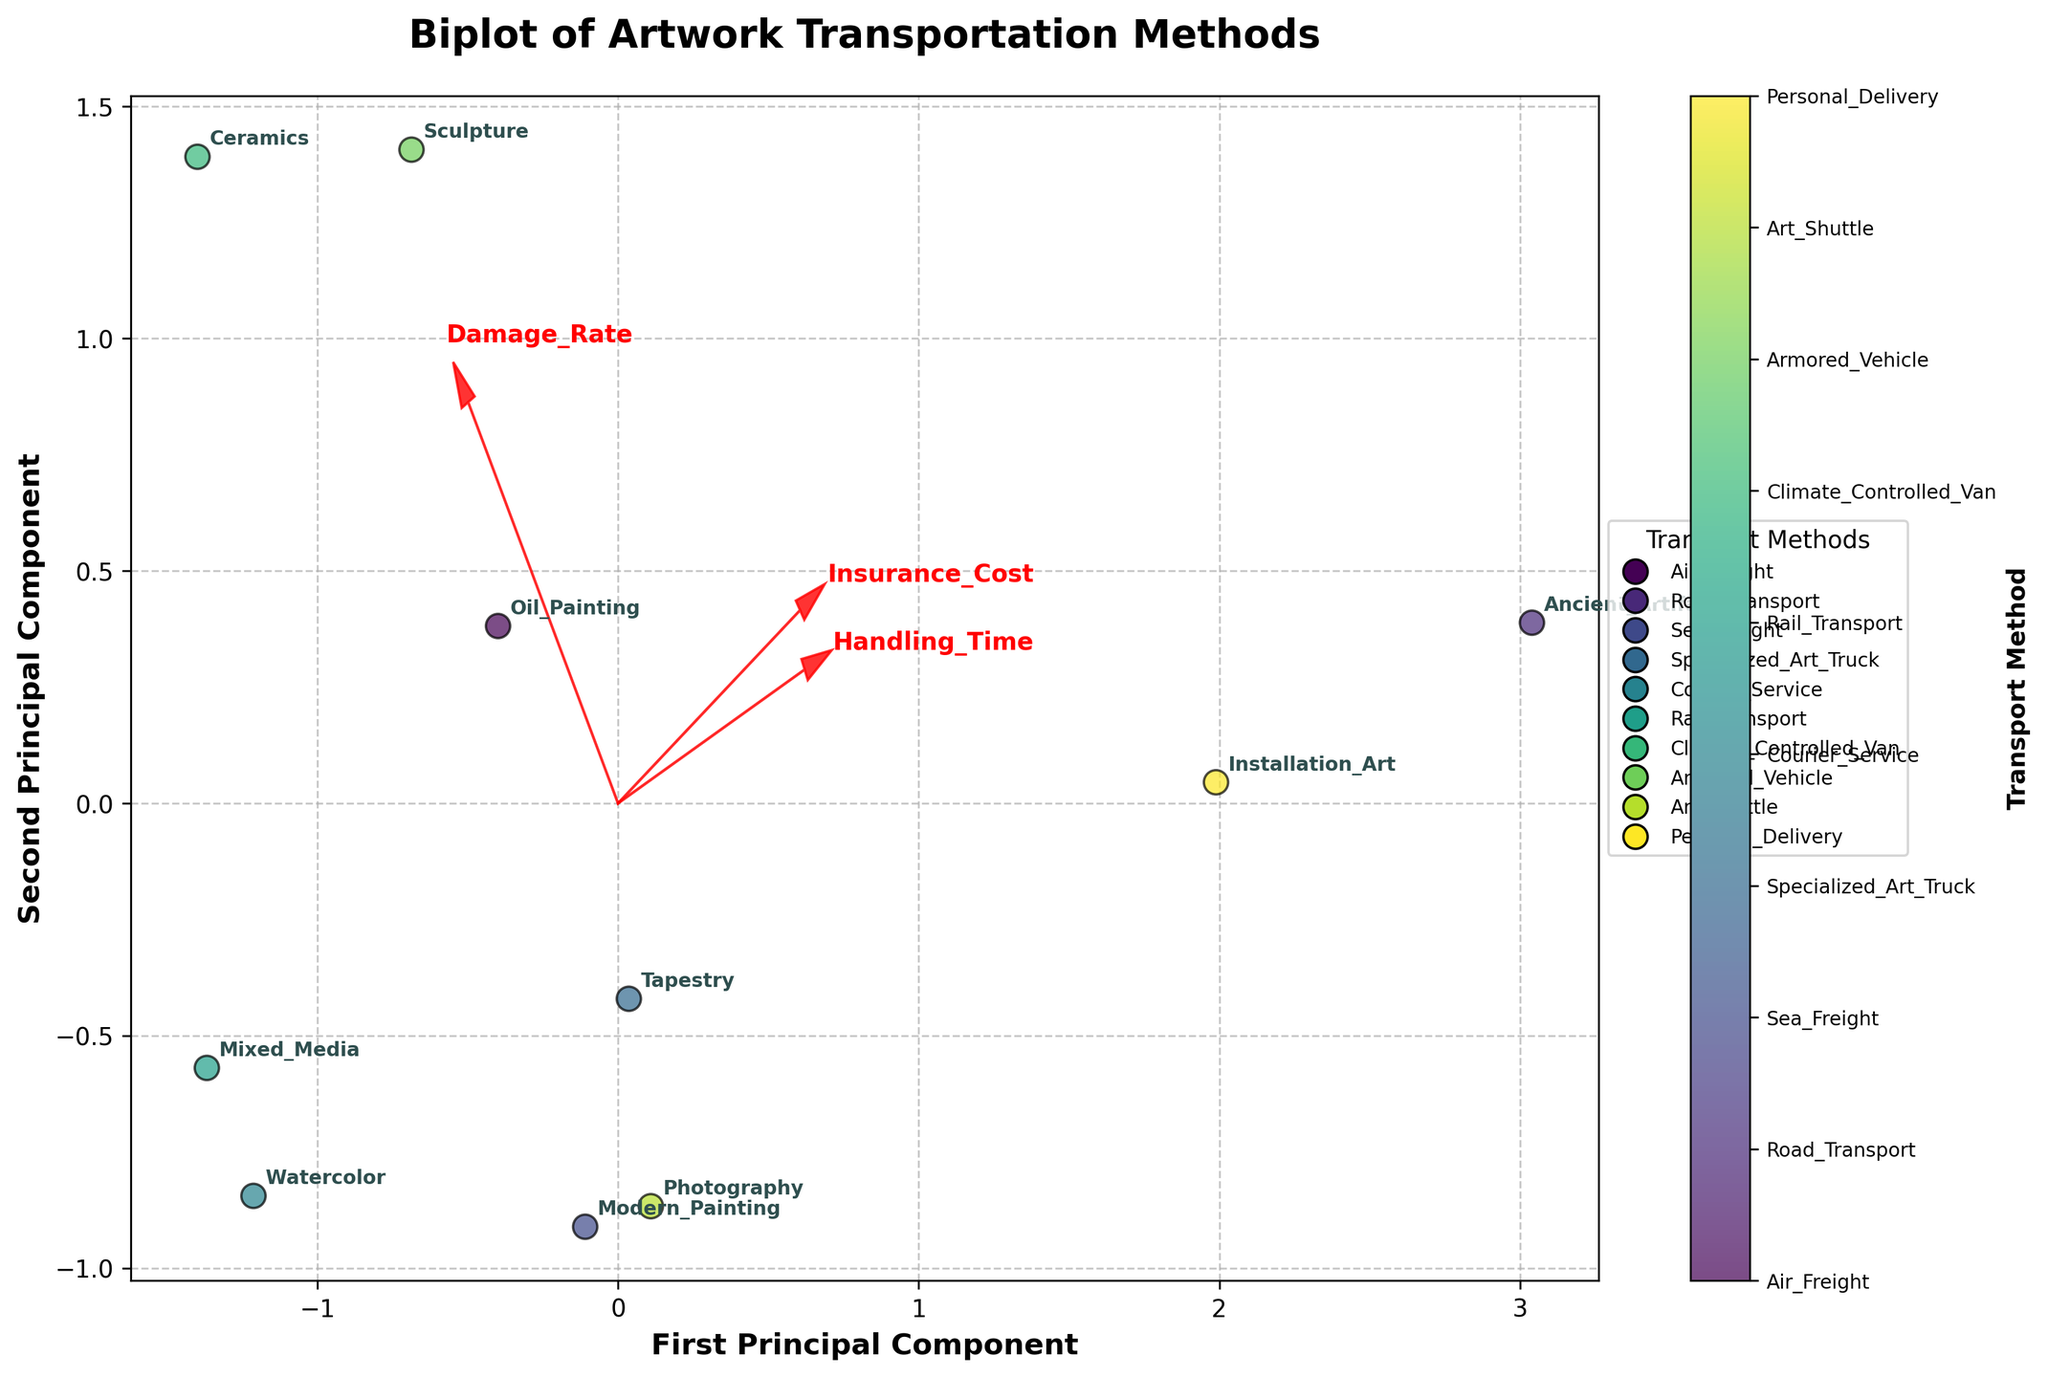What's the title of the plot? The title is displayed at the top center of the plot.
Answer: Biplot of Artwork Transportation Methods How many artwork types are displayed in the plot? Each artwork type corresponds to a different annotation in the plot.
Answer: 10 Which transport method corresponds to the highest damage rate? The plot shows different damage rates; the highest value aligns with Ceramics using Rail Transport.
Answer: Rail Transport Which artwork has the lowest damage rate? The plot shows that the lowest damage rate is annotated as Ancient Artifact.
Answer: Ancient Artifact What are the vectors in red indicating in the plot? The red vectors represent the direction and magnitude of the standardized features (Damage Rate, Insurance Cost, and Handling Time) in the PCA space.
Answer: Features correlation What transport method is used for Modern Painting? The plot annotates Modern Painting and aligns it with the corresponding label in the legend for transport methods; it matches Art Shuttle.
Answer: Art Shuttle Compare the positions of Oil Painting and Installation Art. Which one has a higher Damage Rate? The position of Oil Painting is higher along the vector indicating Damage Rate compared to Installation Art.
Answer: Oil Painting What are the coordinates of the first principal component for Photography? Locate the Photography annotation on the plot and read its x-coordinate value.
Answer: Read from the figure Which feature has the greatest influence on the first principal component? The arrow for the first principal component closest to the x-axis indicates its magnitude; the longest arrow represents Handling Time.
Answer: Handling Time Which principal component does the Insurance Cost vector affect most? The direction of the Insurance Cost vector has a significant projection onto both principal components; however, it's more aligned with the first component.
Answer: First Principal Component 